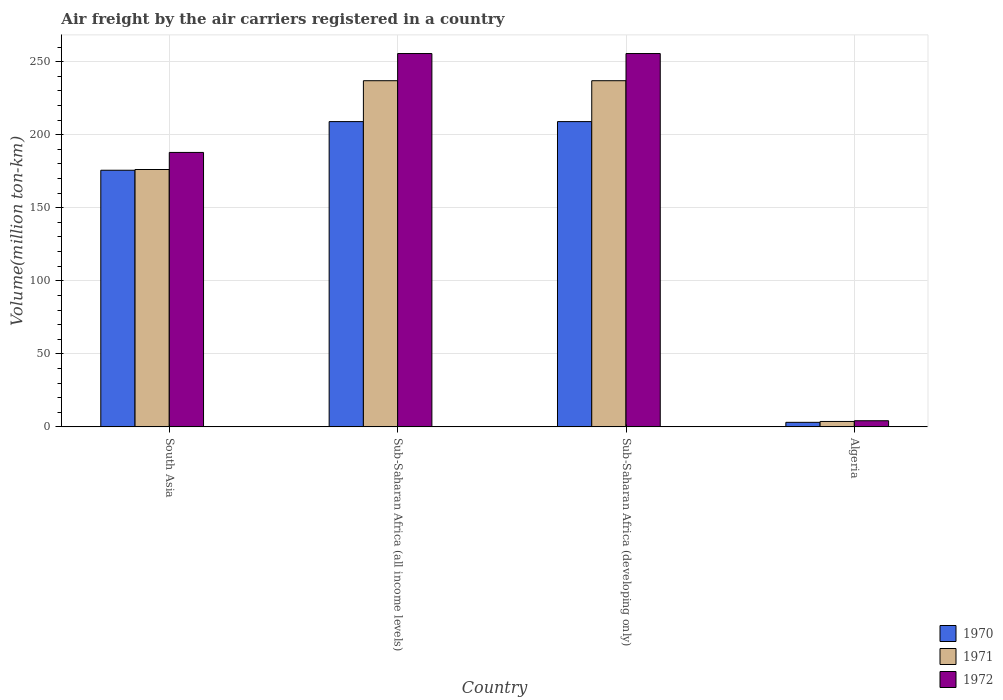How many groups of bars are there?
Your answer should be very brief. 4. Are the number of bars per tick equal to the number of legend labels?
Your answer should be very brief. Yes. How many bars are there on the 3rd tick from the left?
Provide a succinct answer. 3. How many bars are there on the 2nd tick from the right?
Your answer should be very brief. 3. What is the label of the 2nd group of bars from the left?
Make the answer very short. Sub-Saharan Africa (all income levels). In how many cases, is the number of bars for a given country not equal to the number of legend labels?
Make the answer very short. 0. What is the volume of the air carriers in 1971 in Algeria?
Keep it short and to the point. 3.7. Across all countries, what is the maximum volume of the air carriers in 1972?
Offer a terse response. 255.6. Across all countries, what is the minimum volume of the air carriers in 1972?
Your answer should be very brief. 4.2. In which country was the volume of the air carriers in 1972 maximum?
Your response must be concise. Sub-Saharan Africa (all income levels). In which country was the volume of the air carriers in 1970 minimum?
Give a very brief answer. Algeria. What is the total volume of the air carriers in 1970 in the graph?
Make the answer very short. 596.8. What is the difference between the volume of the air carriers in 1972 in Algeria and that in South Asia?
Your response must be concise. -183.7. What is the difference between the volume of the air carriers in 1972 in Sub-Saharan Africa (all income levels) and the volume of the air carriers in 1971 in Algeria?
Give a very brief answer. 251.9. What is the average volume of the air carriers in 1970 per country?
Give a very brief answer. 149.2. What is the difference between the volume of the air carriers of/in 1972 and volume of the air carriers of/in 1970 in South Asia?
Offer a very short reply. 12.2. What is the ratio of the volume of the air carriers in 1972 in Algeria to that in Sub-Saharan Africa (all income levels)?
Keep it short and to the point. 0.02. Is the volume of the air carriers in 1970 in Algeria less than that in Sub-Saharan Africa (all income levels)?
Provide a succinct answer. Yes. What is the difference between the highest and the second highest volume of the air carriers in 1970?
Ensure brevity in your answer.  33.3. What is the difference between the highest and the lowest volume of the air carriers in 1972?
Your answer should be very brief. 251.4. What does the 2nd bar from the right in Sub-Saharan Africa (developing only) represents?
Offer a terse response. 1971. Is it the case that in every country, the sum of the volume of the air carriers in 1971 and volume of the air carriers in 1972 is greater than the volume of the air carriers in 1970?
Ensure brevity in your answer.  Yes. How many countries are there in the graph?
Offer a very short reply. 4. Does the graph contain grids?
Give a very brief answer. Yes. Where does the legend appear in the graph?
Your response must be concise. Bottom right. How are the legend labels stacked?
Make the answer very short. Vertical. What is the title of the graph?
Offer a very short reply. Air freight by the air carriers registered in a country. What is the label or title of the Y-axis?
Offer a terse response. Volume(million ton-km). What is the Volume(million ton-km) of 1970 in South Asia?
Ensure brevity in your answer.  175.7. What is the Volume(million ton-km) in 1971 in South Asia?
Your answer should be very brief. 176.2. What is the Volume(million ton-km) in 1972 in South Asia?
Ensure brevity in your answer.  187.9. What is the Volume(million ton-km) of 1970 in Sub-Saharan Africa (all income levels)?
Ensure brevity in your answer.  209. What is the Volume(million ton-km) of 1971 in Sub-Saharan Africa (all income levels)?
Provide a succinct answer. 237. What is the Volume(million ton-km) of 1972 in Sub-Saharan Africa (all income levels)?
Ensure brevity in your answer.  255.6. What is the Volume(million ton-km) in 1970 in Sub-Saharan Africa (developing only)?
Your answer should be compact. 209. What is the Volume(million ton-km) of 1971 in Sub-Saharan Africa (developing only)?
Keep it short and to the point. 237. What is the Volume(million ton-km) of 1972 in Sub-Saharan Africa (developing only)?
Your response must be concise. 255.6. What is the Volume(million ton-km) of 1970 in Algeria?
Provide a succinct answer. 3.1. What is the Volume(million ton-km) in 1971 in Algeria?
Your response must be concise. 3.7. What is the Volume(million ton-km) in 1972 in Algeria?
Offer a terse response. 4.2. Across all countries, what is the maximum Volume(million ton-km) of 1970?
Provide a succinct answer. 209. Across all countries, what is the maximum Volume(million ton-km) of 1971?
Give a very brief answer. 237. Across all countries, what is the maximum Volume(million ton-km) of 1972?
Your answer should be very brief. 255.6. Across all countries, what is the minimum Volume(million ton-km) in 1970?
Give a very brief answer. 3.1. Across all countries, what is the minimum Volume(million ton-km) of 1971?
Give a very brief answer. 3.7. Across all countries, what is the minimum Volume(million ton-km) of 1972?
Offer a terse response. 4.2. What is the total Volume(million ton-km) in 1970 in the graph?
Provide a short and direct response. 596.8. What is the total Volume(million ton-km) in 1971 in the graph?
Give a very brief answer. 653.9. What is the total Volume(million ton-km) of 1972 in the graph?
Your answer should be compact. 703.3. What is the difference between the Volume(million ton-km) in 1970 in South Asia and that in Sub-Saharan Africa (all income levels)?
Your answer should be compact. -33.3. What is the difference between the Volume(million ton-km) of 1971 in South Asia and that in Sub-Saharan Africa (all income levels)?
Offer a terse response. -60.8. What is the difference between the Volume(million ton-km) of 1972 in South Asia and that in Sub-Saharan Africa (all income levels)?
Your response must be concise. -67.7. What is the difference between the Volume(million ton-km) in 1970 in South Asia and that in Sub-Saharan Africa (developing only)?
Your response must be concise. -33.3. What is the difference between the Volume(million ton-km) of 1971 in South Asia and that in Sub-Saharan Africa (developing only)?
Ensure brevity in your answer.  -60.8. What is the difference between the Volume(million ton-km) in 1972 in South Asia and that in Sub-Saharan Africa (developing only)?
Offer a terse response. -67.7. What is the difference between the Volume(million ton-km) in 1970 in South Asia and that in Algeria?
Your response must be concise. 172.6. What is the difference between the Volume(million ton-km) of 1971 in South Asia and that in Algeria?
Give a very brief answer. 172.5. What is the difference between the Volume(million ton-km) in 1972 in South Asia and that in Algeria?
Offer a very short reply. 183.7. What is the difference between the Volume(million ton-km) of 1970 in Sub-Saharan Africa (all income levels) and that in Sub-Saharan Africa (developing only)?
Offer a very short reply. 0. What is the difference between the Volume(million ton-km) in 1970 in Sub-Saharan Africa (all income levels) and that in Algeria?
Offer a terse response. 205.9. What is the difference between the Volume(million ton-km) in 1971 in Sub-Saharan Africa (all income levels) and that in Algeria?
Keep it short and to the point. 233.3. What is the difference between the Volume(million ton-km) of 1972 in Sub-Saharan Africa (all income levels) and that in Algeria?
Offer a very short reply. 251.4. What is the difference between the Volume(million ton-km) in 1970 in Sub-Saharan Africa (developing only) and that in Algeria?
Ensure brevity in your answer.  205.9. What is the difference between the Volume(million ton-km) of 1971 in Sub-Saharan Africa (developing only) and that in Algeria?
Your answer should be compact. 233.3. What is the difference between the Volume(million ton-km) of 1972 in Sub-Saharan Africa (developing only) and that in Algeria?
Make the answer very short. 251.4. What is the difference between the Volume(million ton-km) in 1970 in South Asia and the Volume(million ton-km) in 1971 in Sub-Saharan Africa (all income levels)?
Keep it short and to the point. -61.3. What is the difference between the Volume(million ton-km) in 1970 in South Asia and the Volume(million ton-km) in 1972 in Sub-Saharan Africa (all income levels)?
Make the answer very short. -79.9. What is the difference between the Volume(million ton-km) in 1971 in South Asia and the Volume(million ton-km) in 1972 in Sub-Saharan Africa (all income levels)?
Give a very brief answer. -79.4. What is the difference between the Volume(million ton-km) of 1970 in South Asia and the Volume(million ton-km) of 1971 in Sub-Saharan Africa (developing only)?
Provide a succinct answer. -61.3. What is the difference between the Volume(million ton-km) in 1970 in South Asia and the Volume(million ton-km) in 1972 in Sub-Saharan Africa (developing only)?
Make the answer very short. -79.9. What is the difference between the Volume(million ton-km) in 1971 in South Asia and the Volume(million ton-km) in 1972 in Sub-Saharan Africa (developing only)?
Provide a succinct answer. -79.4. What is the difference between the Volume(million ton-km) in 1970 in South Asia and the Volume(million ton-km) in 1971 in Algeria?
Your answer should be very brief. 172. What is the difference between the Volume(million ton-km) of 1970 in South Asia and the Volume(million ton-km) of 1972 in Algeria?
Provide a succinct answer. 171.5. What is the difference between the Volume(million ton-km) of 1971 in South Asia and the Volume(million ton-km) of 1972 in Algeria?
Give a very brief answer. 172. What is the difference between the Volume(million ton-km) of 1970 in Sub-Saharan Africa (all income levels) and the Volume(million ton-km) of 1971 in Sub-Saharan Africa (developing only)?
Your answer should be compact. -28. What is the difference between the Volume(million ton-km) of 1970 in Sub-Saharan Africa (all income levels) and the Volume(million ton-km) of 1972 in Sub-Saharan Africa (developing only)?
Provide a succinct answer. -46.6. What is the difference between the Volume(million ton-km) in 1971 in Sub-Saharan Africa (all income levels) and the Volume(million ton-km) in 1972 in Sub-Saharan Africa (developing only)?
Make the answer very short. -18.6. What is the difference between the Volume(million ton-km) of 1970 in Sub-Saharan Africa (all income levels) and the Volume(million ton-km) of 1971 in Algeria?
Your response must be concise. 205.3. What is the difference between the Volume(million ton-km) in 1970 in Sub-Saharan Africa (all income levels) and the Volume(million ton-km) in 1972 in Algeria?
Provide a short and direct response. 204.8. What is the difference between the Volume(million ton-km) in 1971 in Sub-Saharan Africa (all income levels) and the Volume(million ton-km) in 1972 in Algeria?
Your answer should be compact. 232.8. What is the difference between the Volume(million ton-km) of 1970 in Sub-Saharan Africa (developing only) and the Volume(million ton-km) of 1971 in Algeria?
Keep it short and to the point. 205.3. What is the difference between the Volume(million ton-km) in 1970 in Sub-Saharan Africa (developing only) and the Volume(million ton-km) in 1972 in Algeria?
Your response must be concise. 204.8. What is the difference between the Volume(million ton-km) of 1971 in Sub-Saharan Africa (developing only) and the Volume(million ton-km) of 1972 in Algeria?
Your answer should be very brief. 232.8. What is the average Volume(million ton-km) of 1970 per country?
Offer a very short reply. 149.2. What is the average Volume(million ton-km) of 1971 per country?
Ensure brevity in your answer.  163.47. What is the average Volume(million ton-km) of 1972 per country?
Your response must be concise. 175.82. What is the difference between the Volume(million ton-km) of 1970 and Volume(million ton-km) of 1972 in South Asia?
Make the answer very short. -12.2. What is the difference between the Volume(million ton-km) in 1970 and Volume(million ton-km) in 1972 in Sub-Saharan Africa (all income levels)?
Your answer should be compact. -46.6. What is the difference between the Volume(million ton-km) of 1971 and Volume(million ton-km) of 1972 in Sub-Saharan Africa (all income levels)?
Your answer should be very brief. -18.6. What is the difference between the Volume(million ton-km) in 1970 and Volume(million ton-km) in 1972 in Sub-Saharan Africa (developing only)?
Give a very brief answer. -46.6. What is the difference between the Volume(million ton-km) of 1971 and Volume(million ton-km) of 1972 in Sub-Saharan Africa (developing only)?
Your response must be concise. -18.6. What is the difference between the Volume(million ton-km) of 1970 and Volume(million ton-km) of 1971 in Algeria?
Your answer should be compact. -0.6. What is the difference between the Volume(million ton-km) of 1970 and Volume(million ton-km) of 1972 in Algeria?
Make the answer very short. -1.1. What is the ratio of the Volume(million ton-km) in 1970 in South Asia to that in Sub-Saharan Africa (all income levels)?
Provide a short and direct response. 0.84. What is the ratio of the Volume(million ton-km) in 1971 in South Asia to that in Sub-Saharan Africa (all income levels)?
Provide a short and direct response. 0.74. What is the ratio of the Volume(million ton-km) of 1972 in South Asia to that in Sub-Saharan Africa (all income levels)?
Ensure brevity in your answer.  0.74. What is the ratio of the Volume(million ton-km) in 1970 in South Asia to that in Sub-Saharan Africa (developing only)?
Your response must be concise. 0.84. What is the ratio of the Volume(million ton-km) in 1971 in South Asia to that in Sub-Saharan Africa (developing only)?
Provide a succinct answer. 0.74. What is the ratio of the Volume(million ton-km) in 1972 in South Asia to that in Sub-Saharan Africa (developing only)?
Ensure brevity in your answer.  0.74. What is the ratio of the Volume(million ton-km) of 1970 in South Asia to that in Algeria?
Provide a succinct answer. 56.68. What is the ratio of the Volume(million ton-km) of 1971 in South Asia to that in Algeria?
Ensure brevity in your answer.  47.62. What is the ratio of the Volume(million ton-km) in 1972 in South Asia to that in Algeria?
Your response must be concise. 44.74. What is the ratio of the Volume(million ton-km) in 1971 in Sub-Saharan Africa (all income levels) to that in Sub-Saharan Africa (developing only)?
Make the answer very short. 1. What is the ratio of the Volume(million ton-km) in 1970 in Sub-Saharan Africa (all income levels) to that in Algeria?
Offer a very short reply. 67.42. What is the ratio of the Volume(million ton-km) in 1971 in Sub-Saharan Africa (all income levels) to that in Algeria?
Your answer should be very brief. 64.05. What is the ratio of the Volume(million ton-km) of 1972 in Sub-Saharan Africa (all income levels) to that in Algeria?
Offer a terse response. 60.86. What is the ratio of the Volume(million ton-km) of 1970 in Sub-Saharan Africa (developing only) to that in Algeria?
Your response must be concise. 67.42. What is the ratio of the Volume(million ton-km) of 1971 in Sub-Saharan Africa (developing only) to that in Algeria?
Give a very brief answer. 64.05. What is the ratio of the Volume(million ton-km) of 1972 in Sub-Saharan Africa (developing only) to that in Algeria?
Offer a terse response. 60.86. What is the difference between the highest and the second highest Volume(million ton-km) in 1970?
Your answer should be compact. 0. What is the difference between the highest and the second highest Volume(million ton-km) of 1971?
Keep it short and to the point. 0. What is the difference between the highest and the second highest Volume(million ton-km) in 1972?
Ensure brevity in your answer.  0. What is the difference between the highest and the lowest Volume(million ton-km) in 1970?
Give a very brief answer. 205.9. What is the difference between the highest and the lowest Volume(million ton-km) in 1971?
Ensure brevity in your answer.  233.3. What is the difference between the highest and the lowest Volume(million ton-km) of 1972?
Provide a succinct answer. 251.4. 